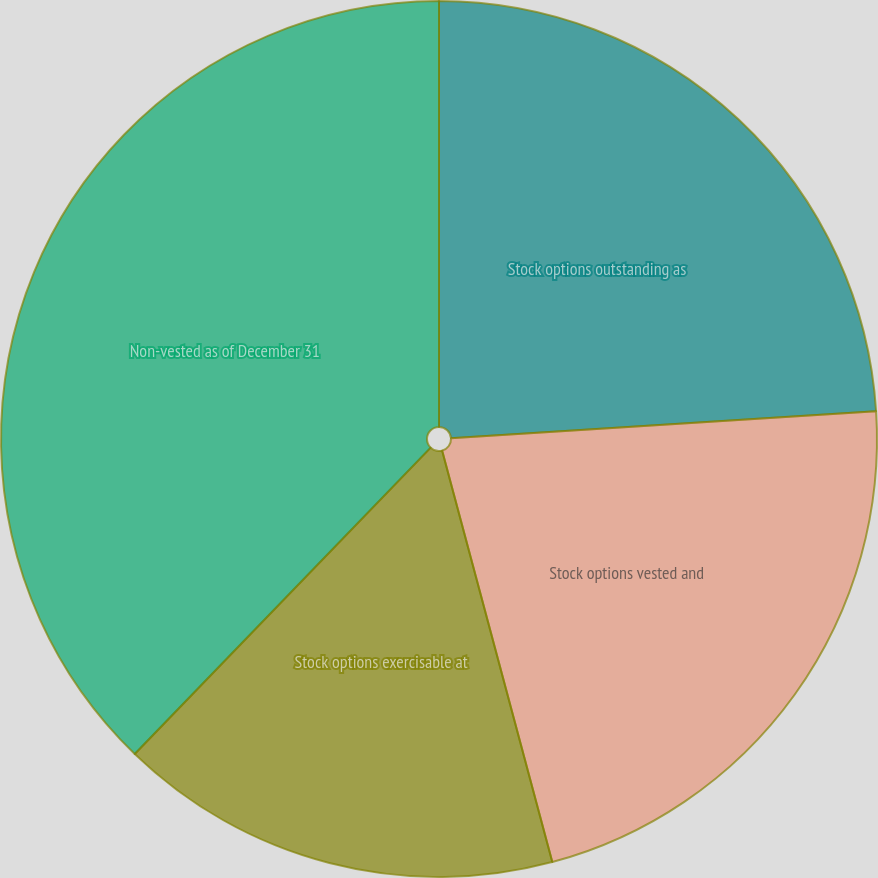<chart> <loc_0><loc_0><loc_500><loc_500><pie_chart><fcel>Stock options outstanding as<fcel>Stock options vested and<fcel>Stock options exercisable at<fcel>Non-vested as of December 31<nl><fcel>23.99%<fcel>21.85%<fcel>16.39%<fcel>37.78%<nl></chart> 